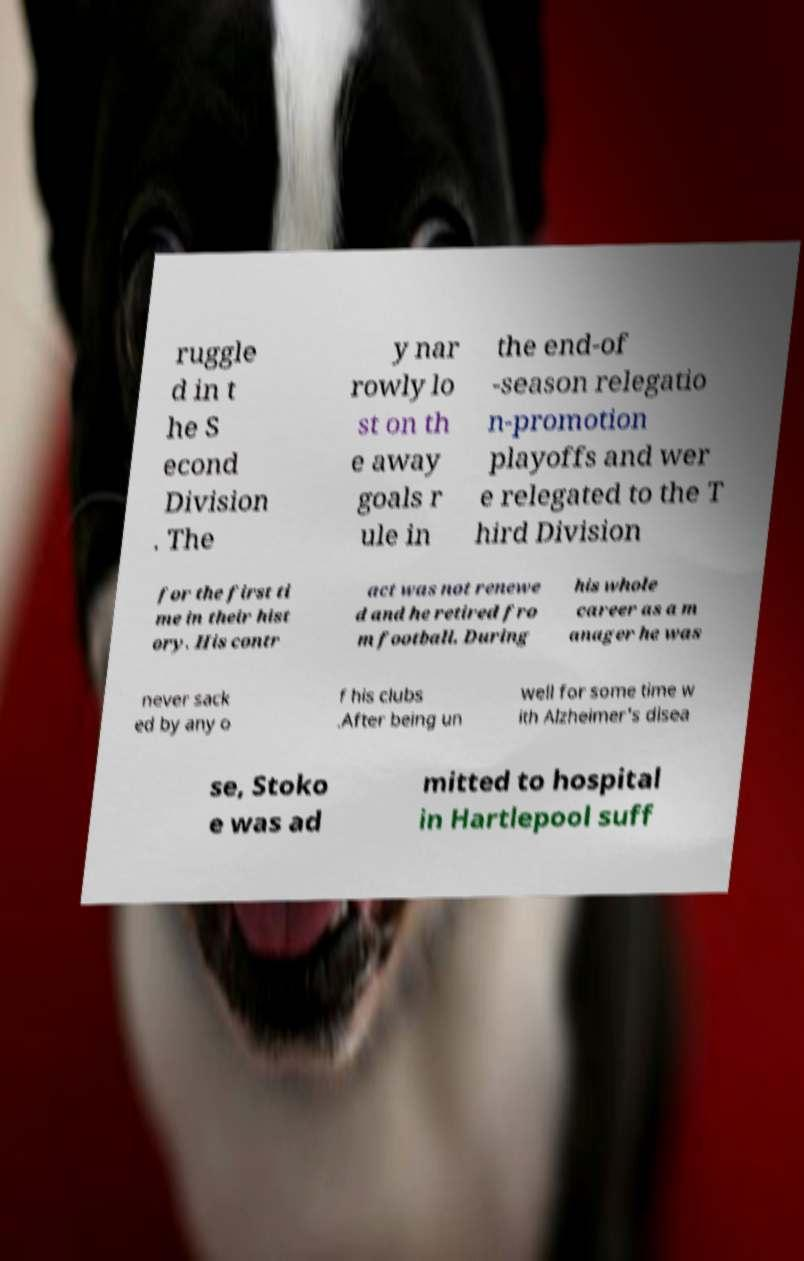What messages or text are displayed in this image? I need them in a readable, typed format. ruggle d in t he S econd Division . The y nar rowly lo st on th e away goals r ule in the end-of -season relegatio n-promotion playoffs and wer e relegated to the T hird Division for the first ti me in their hist ory. His contr act was not renewe d and he retired fro m football. During his whole career as a m anager he was never sack ed by any o f his clubs .After being un well for some time w ith Alzheimer's disea se, Stoko e was ad mitted to hospital in Hartlepool suff 